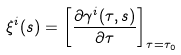Convert formula to latex. <formula><loc_0><loc_0><loc_500><loc_500>\xi ^ { i } ( s ) = \left [ \frac { \partial \gamma ^ { i } ( \tau , s ) } { \partial \tau } \right ] _ { \tau = \tau _ { 0 } }</formula> 